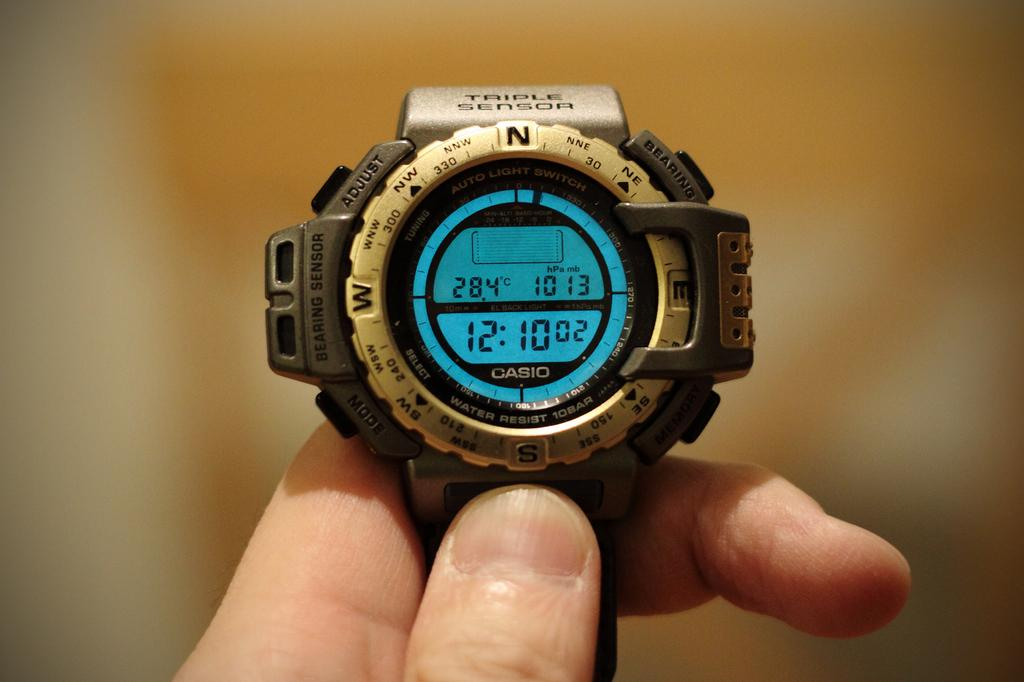<image>
Render a clear and concise summary of the photo. A digital wrist watch named Triple Sensor showing 12:10 02. 